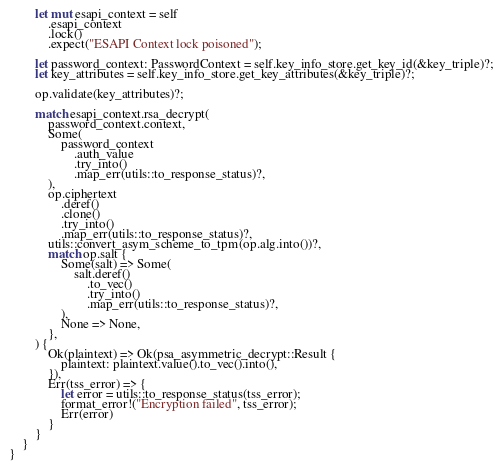Convert code to text. <code><loc_0><loc_0><loc_500><loc_500><_Rust_>        let mut esapi_context = self
            .esapi_context
            .lock()
            .expect("ESAPI Context lock poisoned");

        let password_context: PasswordContext = self.key_info_store.get_key_id(&key_triple)?;
        let key_attributes = self.key_info_store.get_key_attributes(&key_triple)?;

        op.validate(key_attributes)?;

        match esapi_context.rsa_decrypt(
            password_context.context,
            Some(
                password_context
                    .auth_value
                    .try_into()
                    .map_err(utils::to_response_status)?,
            ),
            op.ciphertext
                .deref()
                .clone()
                .try_into()
                .map_err(utils::to_response_status)?,
            utils::convert_asym_scheme_to_tpm(op.alg.into())?,
            match op.salt {
                Some(salt) => Some(
                    salt.deref()
                        .to_vec()
                        .try_into()
                        .map_err(utils::to_response_status)?,
                ),
                None => None,
            },
        ) {
            Ok(plaintext) => Ok(psa_asymmetric_decrypt::Result {
                plaintext: plaintext.value().to_vec().into(),
            }),
            Err(tss_error) => {
                let error = utils::to_response_status(tss_error);
                format_error!("Encryption failed", tss_error);
                Err(error)
            }
        }
    }
}
</code> 